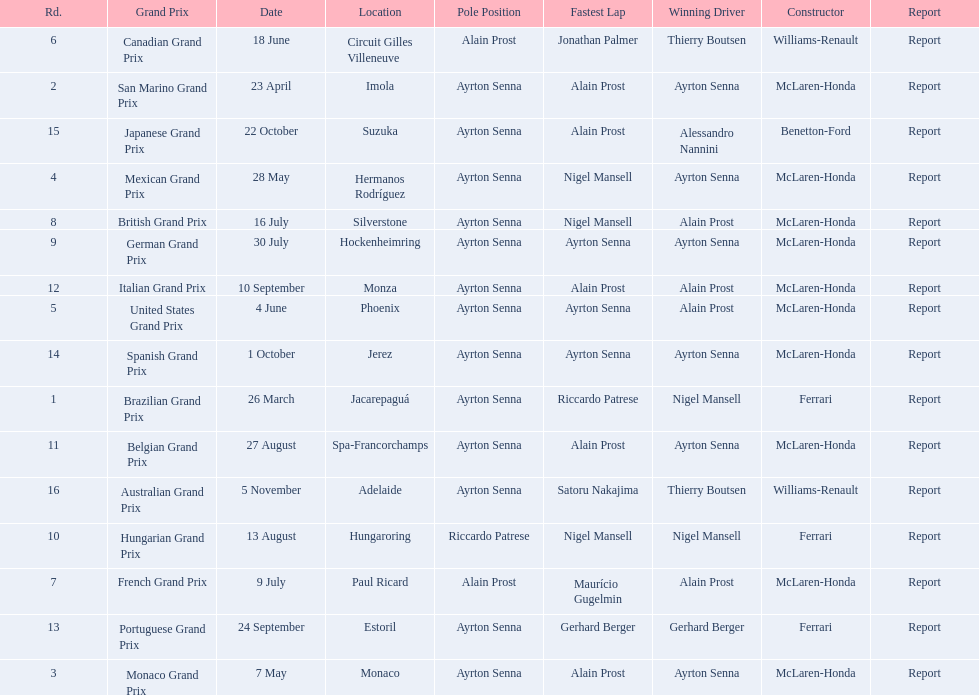Who are the constructors in the 1989 formula one season? Ferrari, McLaren-Honda, McLaren-Honda, McLaren-Honda, McLaren-Honda, Williams-Renault, McLaren-Honda, McLaren-Honda, McLaren-Honda, Ferrari, McLaren-Honda, McLaren-Honda, Ferrari, McLaren-Honda, Benetton-Ford, Williams-Renault. On what date was bennington ford the constructor? 22 October. What was the race on october 22? Japanese Grand Prix. 